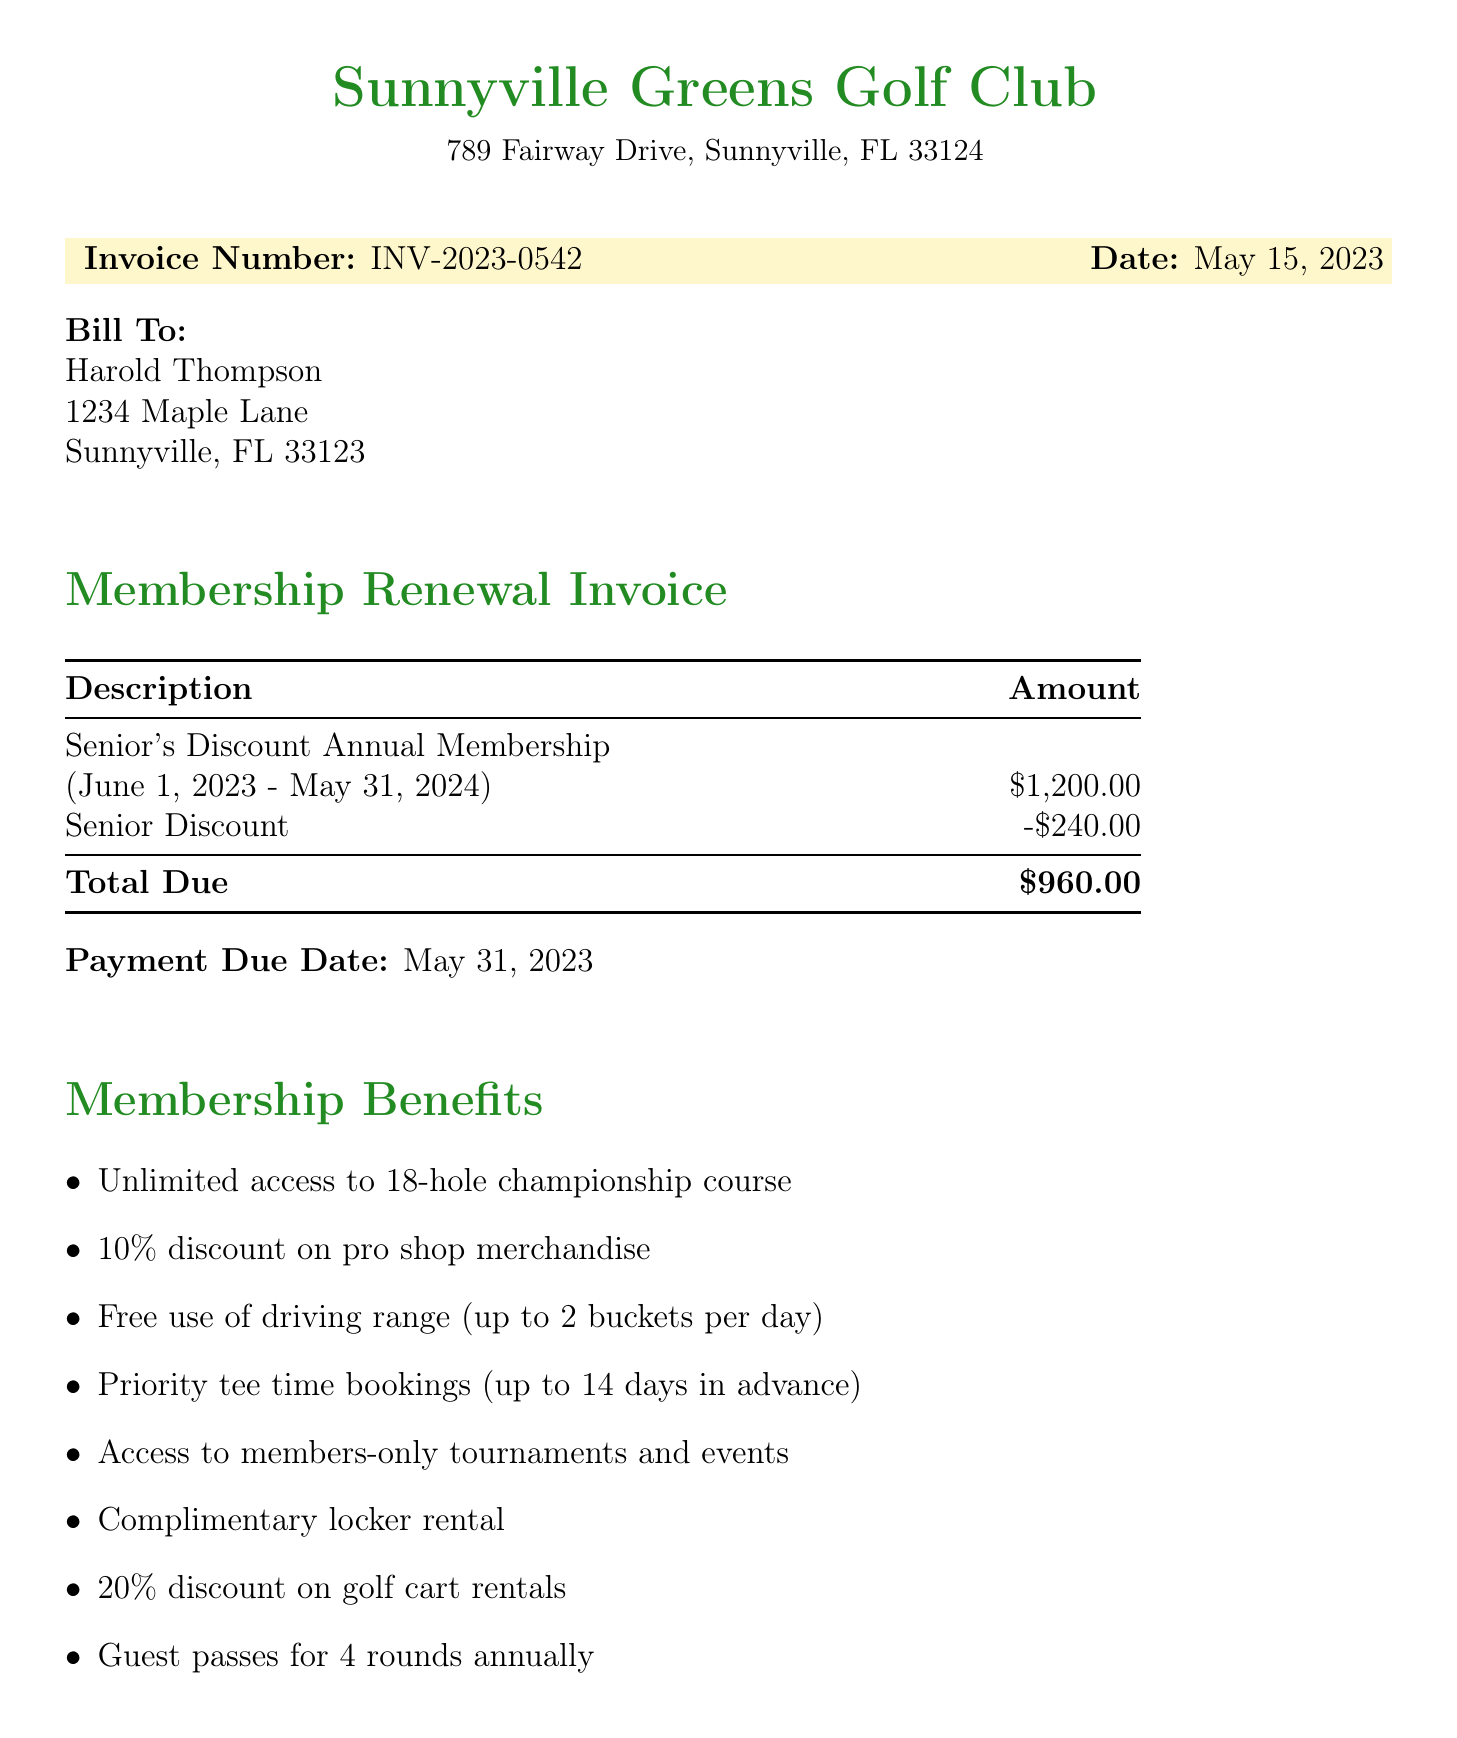What is the invoice number? The invoice number is specifically listed at the top of the document, which is used for tracking purposes.
Answer: INV-2023-0542 What is the total due amount? The total due is the final amount that needs to be paid as indicated in the invoice section.
Answer: $960.00 Who is the client? The client’s name is mentioned at the top of the bill-to section and is important for identifying who the invoice is for.
Answer: Harold Thompson What is the membership type? The membership type specifies the kind of membership being renewed, which impacts the benefits available.
Answer: Senior's Discount Annual Membership When is the payment due date? The payment due date indicates the last date by which the payment must be made to avoid penalties.
Answer: May 31, 2023 What is the duration of the membership period? The membership period details the start and end dates for which the membership benefits are applicable.
Answer: June 1, 2023 - May 31, 2024 How much is the senior discount? The senior discount amount shown in the invoice helps to understand the benefits of being a senior member.
Answer: $240.00 What is one of the benefits of membership? Benefits are specified items that members can enjoy as part of their membership, highlighting its value.
Answer: Unlimited access to 18-hole championship course Who should be contacted for questions? The contact information for inquiries is critical for members needing assistance or clarification.
Answer: Jason Miller 